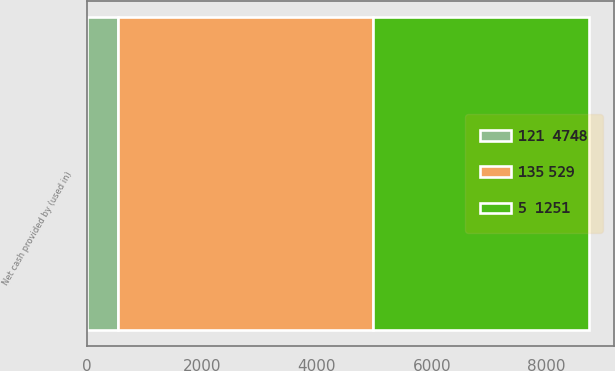<chart> <loc_0><loc_0><loc_500><loc_500><stacked_bar_chart><ecel><fcel>Net cash provided by (used in)<nl><fcel>5  1251<fcel>3763<nl><fcel>135 529<fcel>4432<nl><fcel>121  4748<fcel>539<nl></chart> 